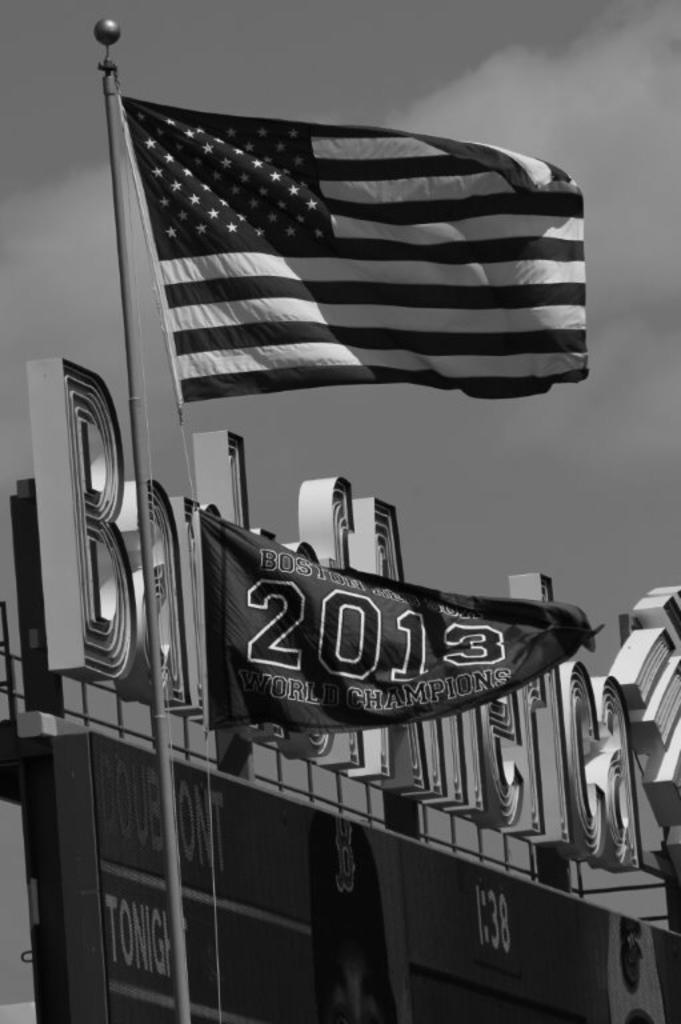<image>
Provide a brief description of the given image. The flag is commemorative of Boston winning in the world championship in 2013. 